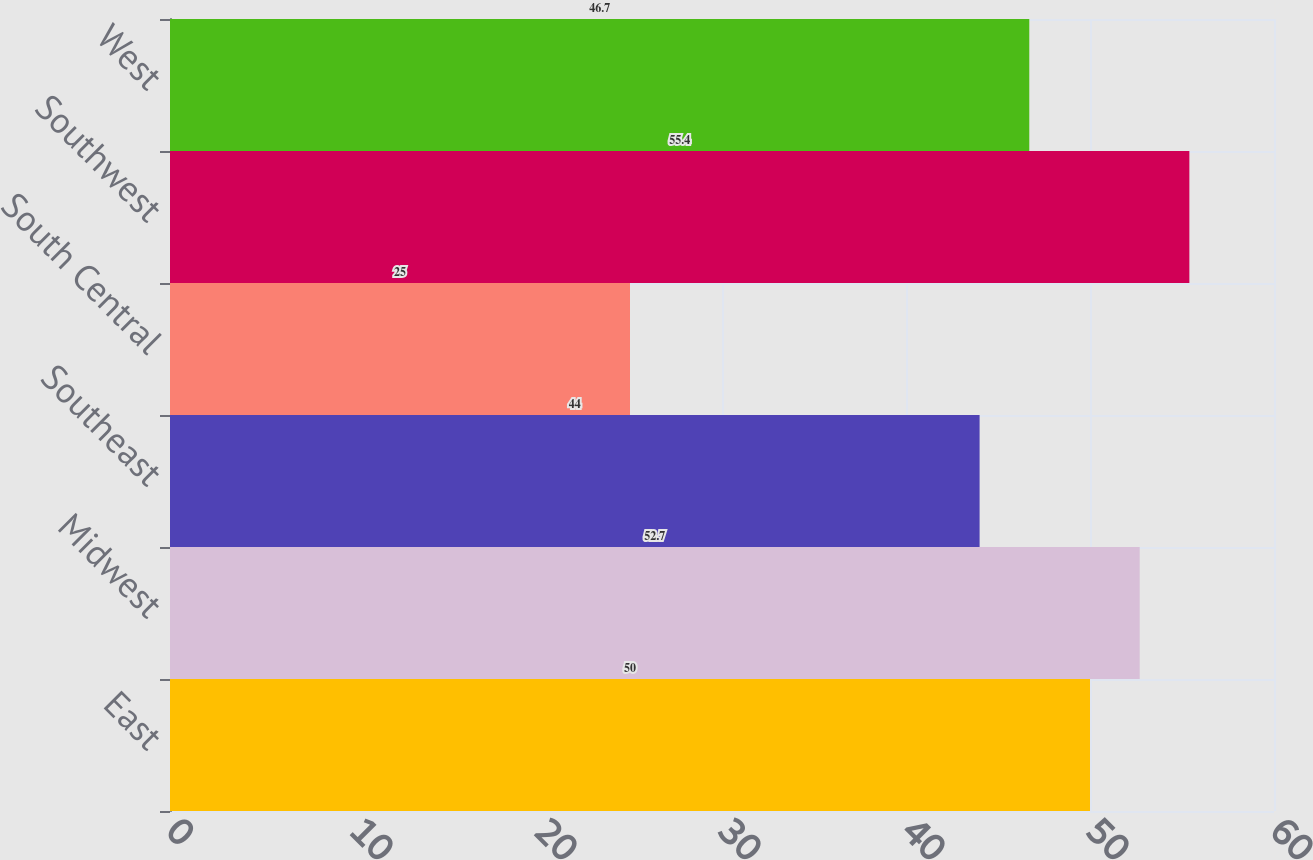Convert chart. <chart><loc_0><loc_0><loc_500><loc_500><bar_chart><fcel>East<fcel>Midwest<fcel>Southeast<fcel>South Central<fcel>Southwest<fcel>West<nl><fcel>50<fcel>52.7<fcel>44<fcel>25<fcel>55.4<fcel>46.7<nl></chart> 